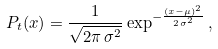<formula> <loc_0><loc_0><loc_500><loc_500>P _ { t } ( x ) = \frac { 1 } { \sqrt { 2 \pi \, \sigma ^ { 2 } } } \exp ^ { - \frac { ( x - \mu ) ^ { 2 } } { 2 \, \sigma ^ { 2 } } } \, ,</formula> 